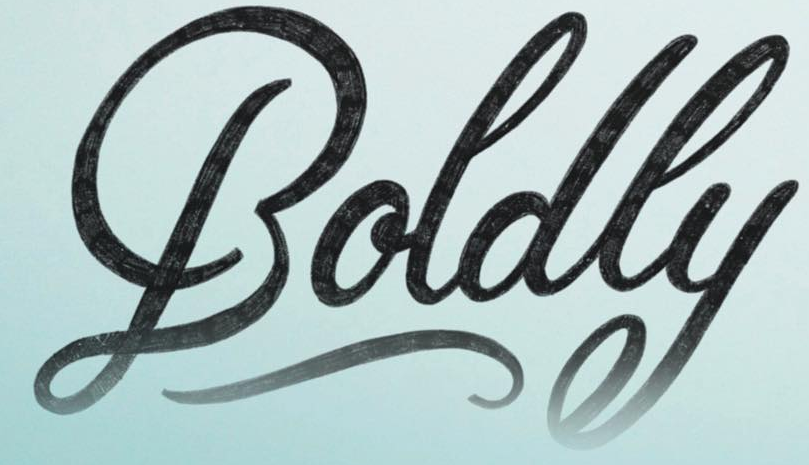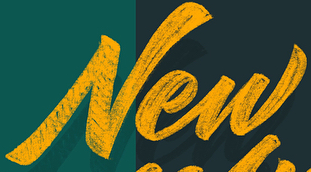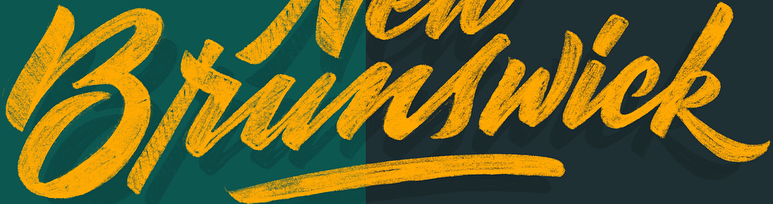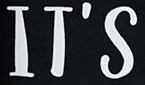Identify the words shown in these images in order, separated by a semicolon. Boldly; New; Brunswick; IT'S 